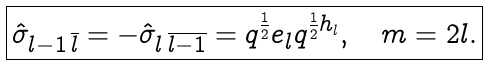<formula> <loc_0><loc_0><loc_500><loc_500>\boxed { \hat { \sigma } _ { l - 1 \, \overline { l } } = - \hat { \sigma } _ { l \, \overline { l - 1 } } = q ^ { \frac { 1 } { 2 } } e _ { l } q ^ { \frac { 1 } { 2 } h _ { l } } , \quad m = 2 l . }</formula> 